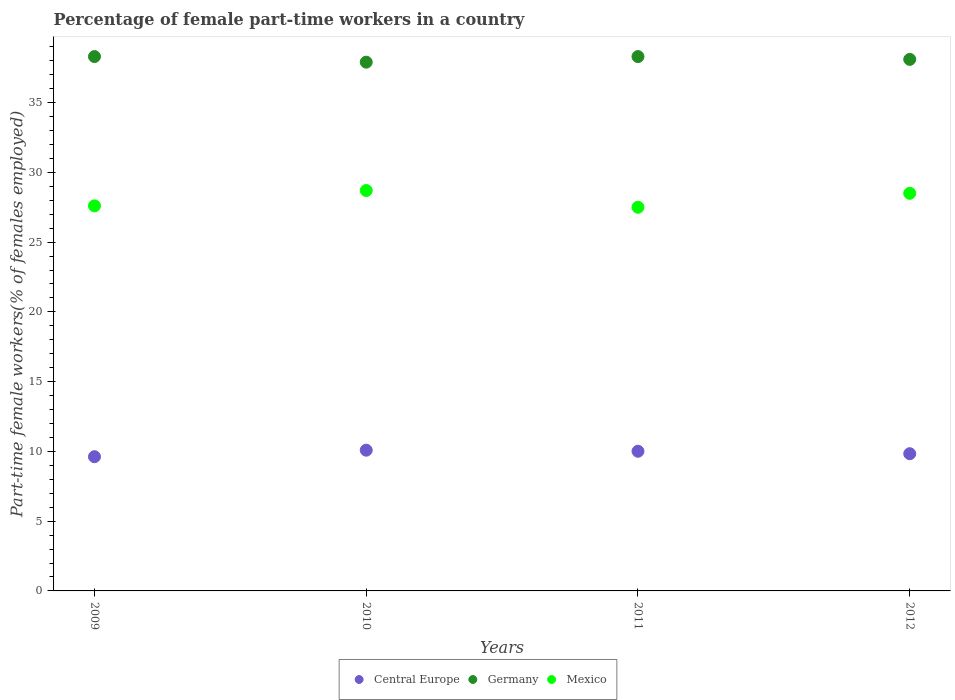What is the percentage of female part-time workers in Mexico in 2009?
Offer a terse response. 27.6. Across all years, what is the maximum percentage of female part-time workers in Central Europe?
Your answer should be compact. 10.09. Across all years, what is the minimum percentage of female part-time workers in Central Europe?
Your answer should be very brief. 9.62. In which year was the percentage of female part-time workers in Mexico maximum?
Provide a succinct answer. 2010. In which year was the percentage of female part-time workers in Central Europe minimum?
Give a very brief answer. 2009. What is the total percentage of female part-time workers in Central Europe in the graph?
Your answer should be very brief. 39.55. What is the difference between the percentage of female part-time workers in Mexico in 2010 and that in 2011?
Provide a succinct answer. 1.2. What is the difference between the percentage of female part-time workers in Central Europe in 2011 and the percentage of female part-time workers in Germany in 2010?
Provide a succinct answer. -27.89. What is the average percentage of female part-time workers in Germany per year?
Offer a terse response. 38.15. In the year 2010, what is the difference between the percentage of female part-time workers in Central Europe and percentage of female part-time workers in Germany?
Your response must be concise. -27.81. What is the ratio of the percentage of female part-time workers in Germany in 2009 to that in 2012?
Your response must be concise. 1.01. Is the percentage of female part-time workers in Mexico in 2009 less than that in 2011?
Offer a very short reply. No. What is the difference between the highest and the second highest percentage of female part-time workers in Mexico?
Offer a very short reply. 0.2. What is the difference between the highest and the lowest percentage of female part-time workers in Mexico?
Make the answer very short. 1.2. In how many years, is the percentage of female part-time workers in Central Europe greater than the average percentage of female part-time workers in Central Europe taken over all years?
Provide a short and direct response. 2. Is it the case that in every year, the sum of the percentage of female part-time workers in Mexico and percentage of female part-time workers in Central Europe  is greater than the percentage of female part-time workers in Germany?
Your answer should be compact. No. Is the percentage of female part-time workers in Germany strictly less than the percentage of female part-time workers in Central Europe over the years?
Your answer should be compact. No. How many dotlines are there?
Your answer should be very brief. 3. Are the values on the major ticks of Y-axis written in scientific E-notation?
Offer a very short reply. No. Does the graph contain any zero values?
Make the answer very short. No. Does the graph contain grids?
Provide a succinct answer. No. How many legend labels are there?
Keep it short and to the point. 3. How are the legend labels stacked?
Keep it short and to the point. Horizontal. What is the title of the graph?
Offer a terse response. Percentage of female part-time workers in a country. Does "American Samoa" appear as one of the legend labels in the graph?
Keep it short and to the point. No. What is the label or title of the X-axis?
Give a very brief answer. Years. What is the label or title of the Y-axis?
Provide a short and direct response. Part-time female workers(% of females employed). What is the Part-time female workers(% of females employed) of Central Europe in 2009?
Provide a succinct answer. 9.62. What is the Part-time female workers(% of females employed) of Germany in 2009?
Your answer should be compact. 38.3. What is the Part-time female workers(% of females employed) of Mexico in 2009?
Offer a terse response. 27.6. What is the Part-time female workers(% of females employed) of Central Europe in 2010?
Offer a terse response. 10.09. What is the Part-time female workers(% of females employed) of Germany in 2010?
Your response must be concise. 37.9. What is the Part-time female workers(% of females employed) of Mexico in 2010?
Give a very brief answer. 28.7. What is the Part-time female workers(% of females employed) of Central Europe in 2011?
Offer a terse response. 10.01. What is the Part-time female workers(% of females employed) of Germany in 2011?
Keep it short and to the point. 38.3. What is the Part-time female workers(% of females employed) in Mexico in 2011?
Offer a very short reply. 27.5. What is the Part-time female workers(% of females employed) in Central Europe in 2012?
Your response must be concise. 9.84. What is the Part-time female workers(% of females employed) of Germany in 2012?
Keep it short and to the point. 38.1. Across all years, what is the maximum Part-time female workers(% of females employed) of Central Europe?
Offer a very short reply. 10.09. Across all years, what is the maximum Part-time female workers(% of females employed) in Germany?
Your answer should be very brief. 38.3. Across all years, what is the maximum Part-time female workers(% of females employed) in Mexico?
Offer a terse response. 28.7. Across all years, what is the minimum Part-time female workers(% of females employed) in Central Europe?
Offer a very short reply. 9.62. Across all years, what is the minimum Part-time female workers(% of females employed) of Germany?
Offer a terse response. 37.9. What is the total Part-time female workers(% of females employed) of Central Europe in the graph?
Make the answer very short. 39.55. What is the total Part-time female workers(% of females employed) of Germany in the graph?
Provide a succinct answer. 152.6. What is the total Part-time female workers(% of females employed) in Mexico in the graph?
Give a very brief answer. 112.3. What is the difference between the Part-time female workers(% of females employed) of Central Europe in 2009 and that in 2010?
Give a very brief answer. -0.47. What is the difference between the Part-time female workers(% of females employed) of Mexico in 2009 and that in 2010?
Offer a terse response. -1.1. What is the difference between the Part-time female workers(% of females employed) in Central Europe in 2009 and that in 2011?
Your answer should be very brief. -0.39. What is the difference between the Part-time female workers(% of females employed) in Germany in 2009 and that in 2011?
Give a very brief answer. 0. What is the difference between the Part-time female workers(% of females employed) of Central Europe in 2009 and that in 2012?
Provide a succinct answer. -0.21. What is the difference between the Part-time female workers(% of females employed) of Mexico in 2009 and that in 2012?
Offer a terse response. -0.9. What is the difference between the Part-time female workers(% of females employed) in Central Europe in 2010 and that in 2011?
Offer a terse response. 0.08. What is the difference between the Part-time female workers(% of females employed) in Germany in 2010 and that in 2011?
Offer a terse response. -0.4. What is the difference between the Part-time female workers(% of females employed) of Mexico in 2010 and that in 2011?
Your response must be concise. 1.2. What is the difference between the Part-time female workers(% of females employed) in Central Europe in 2010 and that in 2012?
Make the answer very short. 0.25. What is the difference between the Part-time female workers(% of females employed) of Central Europe in 2011 and that in 2012?
Your answer should be compact. 0.17. What is the difference between the Part-time female workers(% of females employed) of Germany in 2011 and that in 2012?
Provide a short and direct response. 0.2. What is the difference between the Part-time female workers(% of females employed) in Central Europe in 2009 and the Part-time female workers(% of females employed) in Germany in 2010?
Offer a terse response. -28.28. What is the difference between the Part-time female workers(% of females employed) in Central Europe in 2009 and the Part-time female workers(% of females employed) in Mexico in 2010?
Provide a short and direct response. -19.08. What is the difference between the Part-time female workers(% of females employed) of Germany in 2009 and the Part-time female workers(% of females employed) of Mexico in 2010?
Provide a short and direct response. 9.6. What is the difference between the Part-time female workers(% of females employed) in Central Europe in 2009 and the Part-time female workers(% of females employed) in Germany in 2011?
Your response must be concise. -28.68. What is the difference between the Part-time female workers(% of females employed) in Central Europe in 2009 and the Part-time female workers(% of females employed) in Mexico in 2011?
Your answer should be very brief. -17.88. What is the difference between the Part-time female workers(% of females employed) of Central Europe in 2009 and the Part-time female workers(% of females employed) of Germany in 2012?
Keep it short and to the point. -28.48. What is the difference between the Part-time female workers(% of females employed) in Central Europe in 2009 and the Part-time female workers(% of females employed) in Mexico in 2012?
Provide a short and direct response. -18.88. What is the difference between the Part-time female workers(% of females employed) of Germany in 2009 and the Part-time female workers(% of females employed) of Mexico in 2012?
Make the answer very short. 9.8. What is the difference between the Part-time female workers(% of females employed) of Central Europe in 2010 and the Part-time female workers(% of females employed) of Germany in 2011?
Your response must be concise. -28.21. What is the difference between the Part-time female workers(% of females employed) in Central Europe in 2010 and the Part-time female workers(% of females employed) in Mexico in 2011?
Your answer should be compact. -17.41. What is the difference between the Part-time female workers(% of females employed) in Germany in 2010 and the Part-time female workers(% of females employed) in Mexico in 2011?
Give a very brief answer. 10.4. What is the difference between the Part-time female workers(% of females employed) in Central Europe in 2010 and the Part-time female workers(% of females employed) in Germany in 2012?
Offer a terse response. -28.01. What is the difference between the Part-time female workers(% of females employed) of Central Europe in 2010 and the Part-time female workers(% of females employed) of Mexico in 2012?
Ensure brevity in your answer.  -18.41. What is the difference between the Part-time female workers(% of females employed) in Central Europe in 2011 and the Part-time female workers(% of females employed) in Germany in 2012?
Your answer should be compact. -28.09. What is the difference between the Part-time female workers(% of females employed) in Central Europe in 2011 and the Part-time female workers(% of females employed) in Mexico in 2012?
Offer a very short reply. -18.49. What is the difference between the Part-time female workers(% of females employed) in Germany in 2011 and the Part-time female workers(% of females employed) in Mexico in 2012?
Your answer should be very brief. 9.8. What is the average Part-time female workers(% of females employed) in Central Europe per year?
Your response must be concise. 9.89. What is the average Part-time female workers(% of females employed) in Germany per year?
Ensure brevity in your answer.  38.15. What is the average Part-time female workers(% of females employed) in Mexico per year?
Provide a short and direct response. 28.07. In the year 2009, what is the difference between the Part-time female workers(% of females employed) of Central Europe and Part-time female workers(% of females employed) of Germany?
Your answer should be very brief. -28.68. In the year 2009, what is the difference between the Part-time female workers(% of females employed) in Central Europe and Part-time female workers(% of females employed) in Mexico?
Offer a very short reply. -17.98. In the year 2010, what is the difference between the Part-time female workers(% of females employed) in Central Europe and Part-time female workers(% of females employed) in Germany?
Provide a short and direct response. -27.81. In the year 2010, what is the difference between the Part-time female workers(% of females employed) in Central Europe and Part-time female workers(% of females employed) in Mexico?
Provide a short and direct response. -18.61. In the year 2011, what is the difference between the Part-time female workers(% of females employed) in Central Europe and Part-time female workers(% of females employed) in Germany?
Keep it short and to the point. -28.29. In the year 2011, what is the difference between the Part-time female workers(% of females employed) in Central Europe and Part-time female workers(% of females employed) in Mexico?
Provide a short and direct response. -17.49. In the year 2011, what is the difference between the Part-time female workers(% of females employed) of Germany and Part-time female workers(% of females employed) of Mexico?
Provide a short and direct response. 10.8. In the year 2012, what is the difference between the Part-time female workers(% of females employed) of Central Europe and Part-time female workers(% of females employed) of Germany?
Offer a terse response. -28.26. In the year 2012, what is the difference between the Part-time female workers(% of females employed) of Central Europe and Part-time female workers(% of females employed) of Mexico?
Provide a succinct answer. -18.66. In the year 2012, what is the difference between the Part-time female workers(% of females employed) of Germany and Part-time female workers(% of females employed) of Mexico?
Offer a very short reply. 9.6. What is the ratio of the Part-time female workers(% of females employed) in Central Europe in 2009 to that in 2010?
Provide a short and direct response. 0.95. What is the ratio of the Part-time female workers(% of females employed) of Germany in 2009 to that in 2010?
Keep it short and to the point. 1.01. What is the ratio of the Part-time female workers(% of females employed) of Mexico in 2009 to that in 2010?
Give a very brief answer. 0.96. What is the ratio of the Part-time female workers(% of females employed) of Central Europe in 2009 to that in 2011?
Offer a terse response. 0.96. What is the ratio of the Part-time female workers(% of females employed) in Germany in 2009 to that in 2011?
Provide a short and direct response. 1. What is the ratio of the Part-time female workers(% of females employed) in Central Europe in 2009 to that in 2012?
Keep it short and to the point. 0.98. What is the ratio of the Part-time female workers(% of females employed) of Mexico in 2009 to that in 2012?
Your response must be concise. 0.97. What is the ratio of the Part-time female workers(% of females employed) in Central Europe in 2010 to that in 2011?
Your response must be concise. 1.01. What is the ratio of the Part-time female workers(% of females employed) of Mexico in 2010 to that in 2011?
Make the answer very short. 1.04. What is the ratio of the Part-time female workers(% of females employed) in Central Europe in 2010 to that in 2012?
Make the answer very short. 1.03. What is the ratio of the Part-time female workers(% of females employed) of Germany in 2010 to that in 2012?
Offer a terse response. 0.99. What is the ratio of the Part-time female workers(% of females employed) in Mexico in 2010 to that in 2012?
Provide a succinct answer. 1.01. What is the ratio of the Part-time female workers(% of females employed) of Central Europe in 2011 to that in 2012?
Your response must be concise. 1.02. What is the ratio of the Part-time female workers(% of females employed) of Germany in 2011 to that in 2012?
Your response must be concise. 1.01. What is the ratio of the Part-time female workers(% of females employed) of Mexico in 2011 to that in 2012?
Your response must be concise. 0.96. What is the difference between the highest and the second highest Part-time female workers(% of females employed) of Central Europe?
Keep it short and to the point. 0.08. What is the difference between the highest and the second highest Part-time female workers(% of females employed) of Mexico?
Give a very brief answer. 0.2. What is the difference between the highest and the lowest Part-time female workers(% of females employed) of Central Europe?
Ensure brevity in your answer.  0.47. 